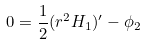<formula> <loc_0><loc_0><loc_500><loc_500>0 = \frac { 1 } { 2 } ( r ^ { 2 } H _ { 1 } ) ^ { \prime } - \phi _ { 2 }</formula> 